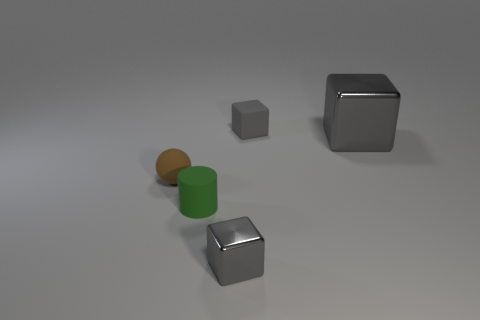Subtract all small cubes. How many cubes are left? 1 Add 2 tiny rubber objects. How many objects exist? 7 Subtract all blocks. How many objects are left? 2 Add 5 blue rubber things. How many blue rubber things exist? 5 Subtract 0 purple cylinders. How many objects are left? 5 Subtract all purple objects. Subtract all small brown rubber spheres. How many objects are left? 4 Add 3 big gray shiny objects. How many big gray shiny objects are left? 4 